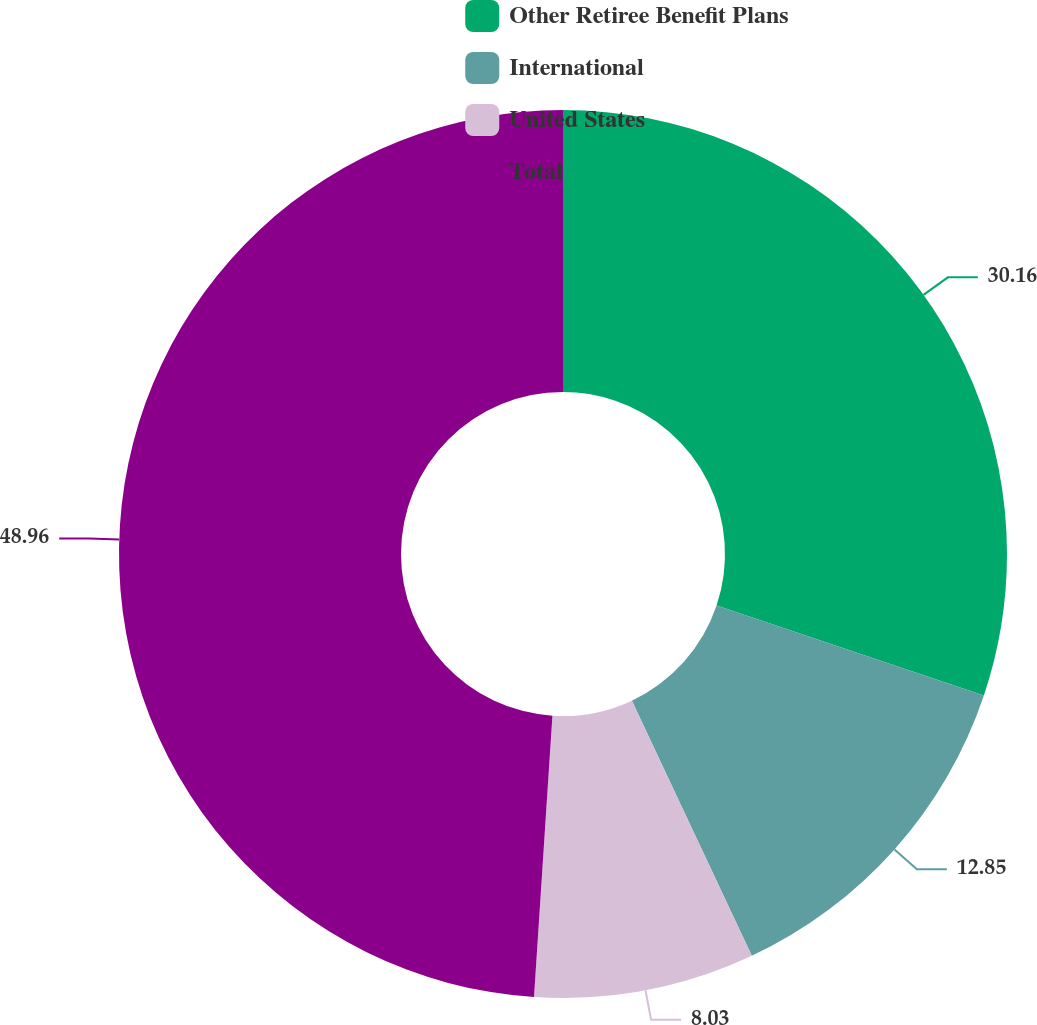Convert chart. <chart><loc_0><loc_0><loc_500><loc_500><pie_chart><fcel>Other Retiree Benefit Plans<fcel>International<fcel>United States<fcel>Total<nl><fcel>30.16%<fcel>12.85%<fcel>8.03%<fcel>48.96%<nl></chart> 